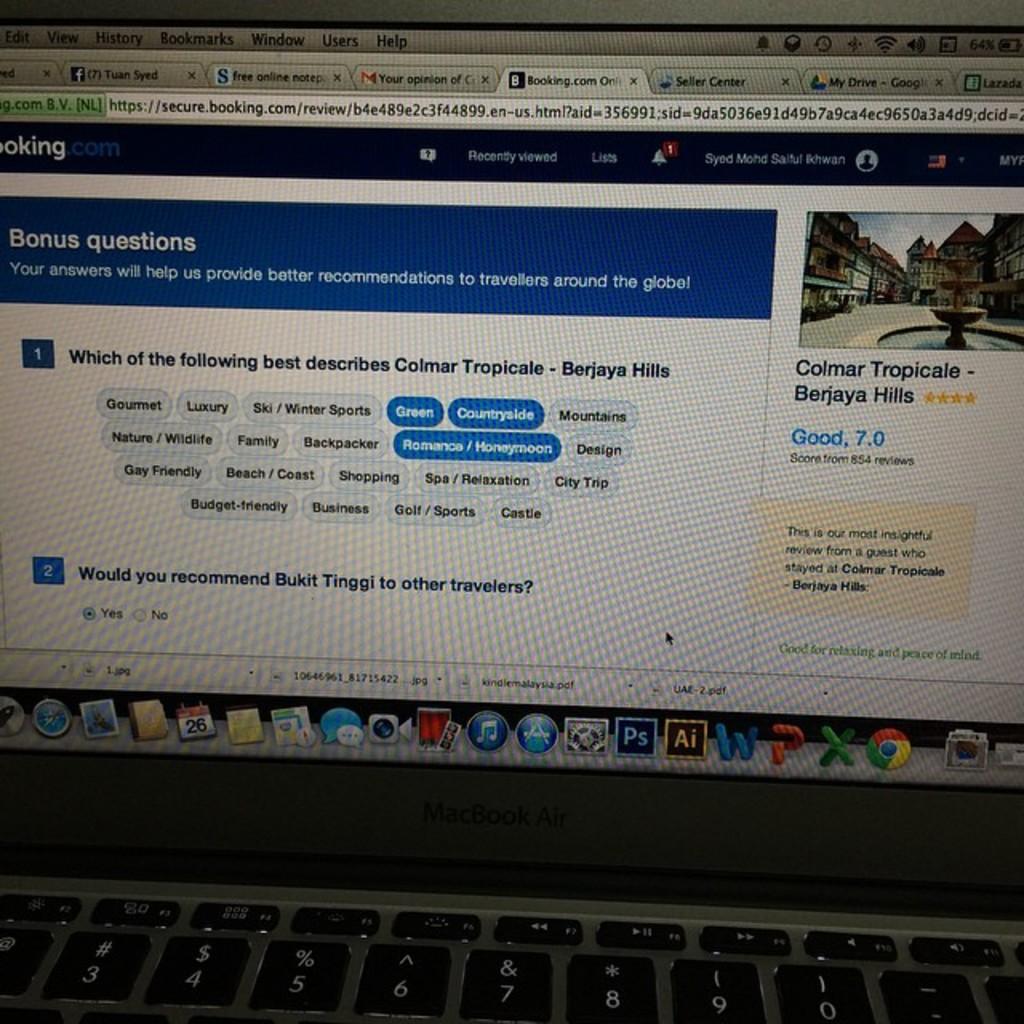What is the name of the shop?
Your answer should be compact. Booking.com. What kind of question is this?
Make the answer very short. Bonus. 